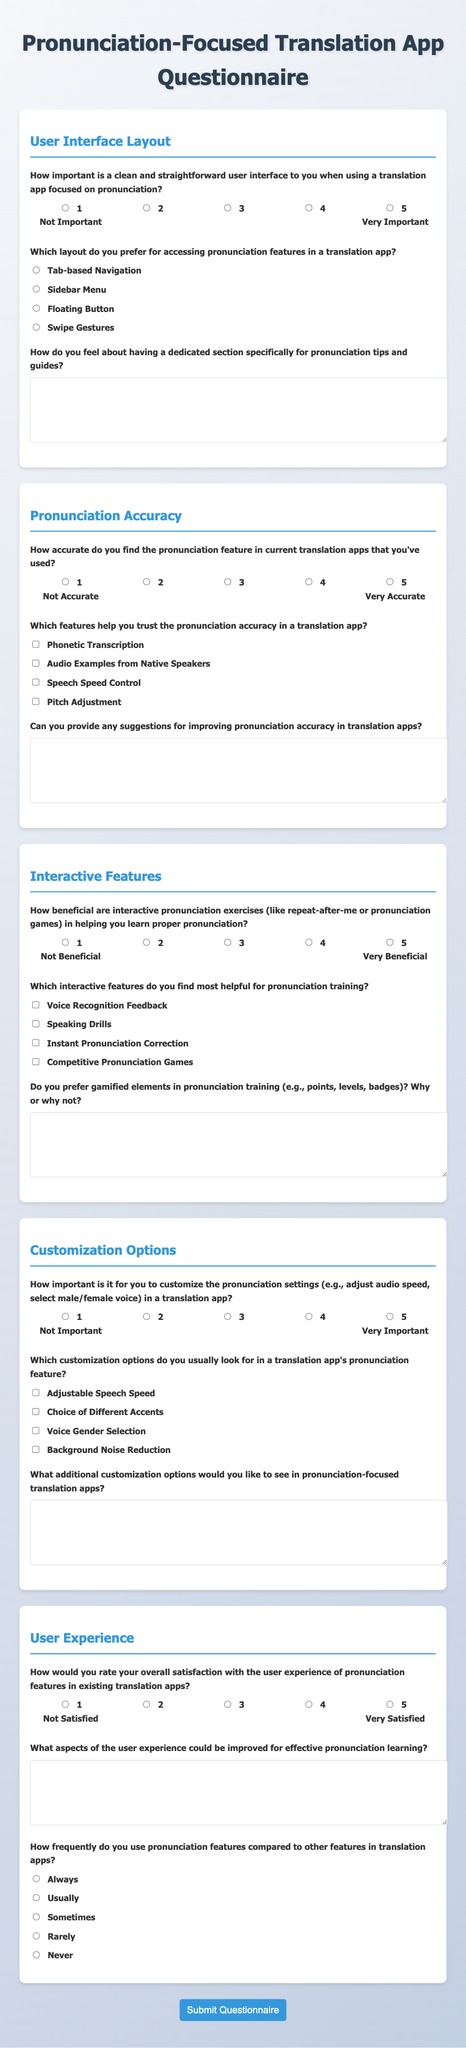What is the title of the questionnaire? The title of the questionnaire is presented at the top of the document, highlighting its focus on pronunciation in translation apps.
Answer: Pronunciation-Focused Translation App Questionnaire How many sections are in the questionnaire? The document is divided into distinct sections, each addressing various aspects of pronunciation and user experience.
Answer: Four What is the maximum score a user can give for the importance of a clean user interface? The questionnaire provides a scale for rating, which ranges from 1 to 5, with 5 being the highest score.
Answer: 5 Which layout option allows access to pronunciation features through gestures? Among the layout options provided, swipe gestures are explicitly mentioned as a choice for accessing features.
Answer: Swipe Gestures What is one customization option users can adjust in the translation app? The document lists several customization options, one of which is the ability to adjust speech speed.
Answer: Adjustable Speech Speed How beneficial do users find interactive pronunciation exercises on a scale of 1 to 5? The questionnaire includes a scale for this question, indicating that users can rate the benefit from 1 (Not Beneficial) to 5 (Very Beneficial).
Answer: 1 to 5 Which feature enjoys the highest priority for enhancing pronunciation accuracy? The document mentions several features, with audio examples from native speakers often regarded as a critical factor for trust in accuracy.
Answer: Audio Examples from Native Speakers What information do users provide regarding their satisfaction with existing translation apps? Users are asked to rate their overall satisfaction, which ranges from not satisfied to very satisfied on a specific scale.
Answer: 1 to 5 What type of feedback helps build trust in pronunciation accuracy? The document lists multiple options, and voice recognition feedback is one such feature that enhances trust in pronunciation accuracy.
Answer: Voice Recognition Feedback 